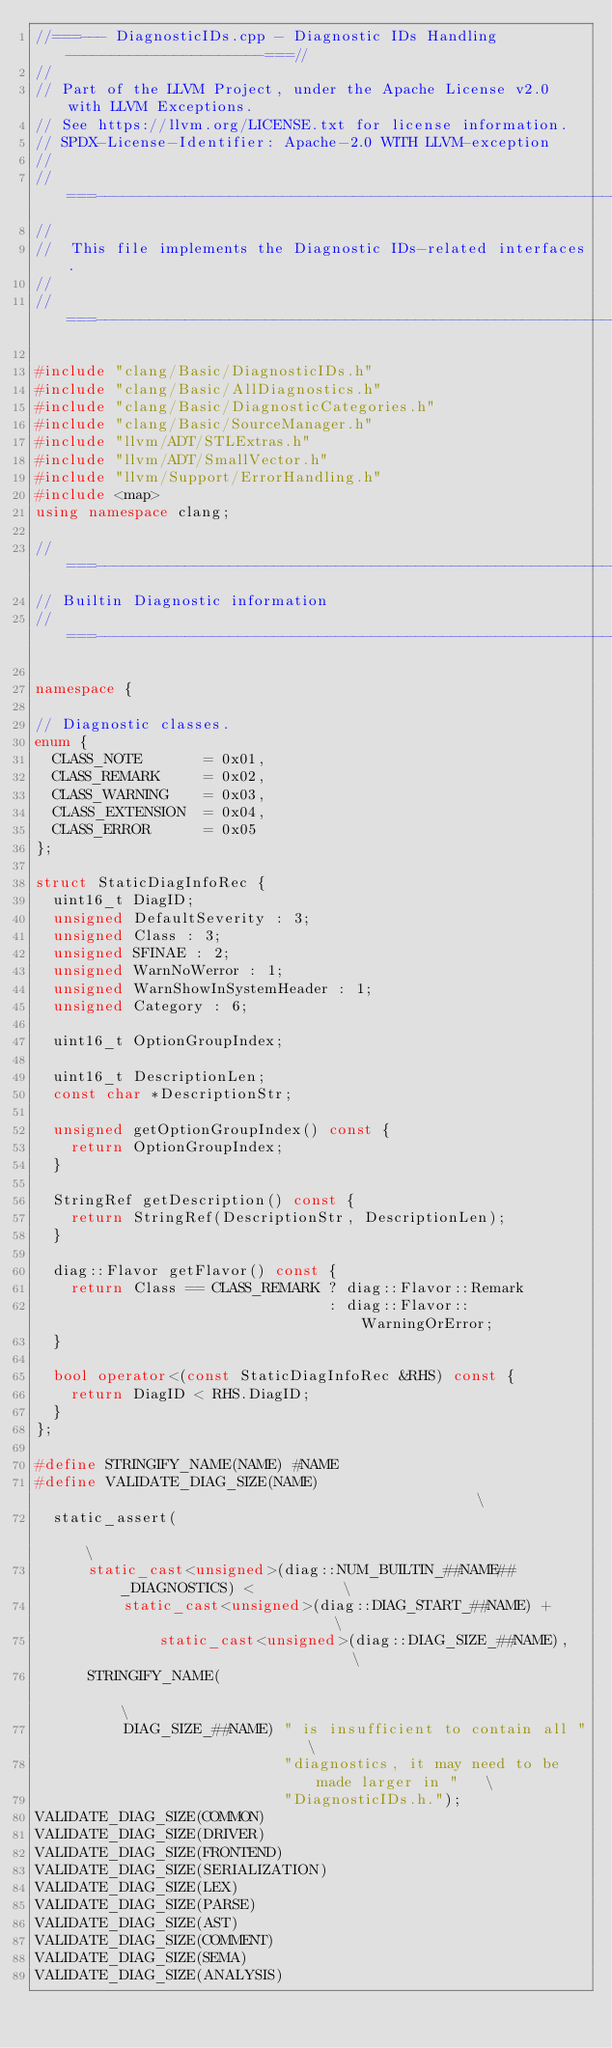Convert code to text. <code><loc_0><loc_0><loc_500><loc_500><_C++_>//===--- DiagnosticIDs.cpp - Diagnostic IDs Handling ----------------------===//
//
// Part of the LLVM Project, under the Apache License v2.0 with LLVM Exceptions.
// See https://llvm.org/LICENSE.txt for license information.
// SPDX-License-Identifier: Apache-2.0 WITH LLVM-exception
//
//===----------------------------------------------------------------------===//
//
//  This file implements the Diagnostic IDs-related interfaces.
//
//===----------------------------------------------------------------------===//

#include "clang/Basic/DiagnosticIDs.h"
#include "clang/Basic/AllDiagnostics.h"
#include "clang/Basic/DiagnosticCategories.h"
#include "clang/Basic/SourceManager.h"
#include "llvm/ADT/STLExtras.h"
#include "llvm/ADT/SmallVector.h"
#include "llvm/Support/ErrorHandling.h"
#include <map>
using namespace clang;

//===----------------------------------------------------------------------===//
// Builtin Diagnostic information
//===----------------------------------------------------------------------===//

namespace {

// Diagnostic classes.
enum {
  CLASS_NOTE       = 0x01,
  CLASS_REMARK     = 0x02,
  CLASS_WARNING    = 0x03,
  CLASS_EXTENSION  = 0x04,
  CLASS_ERROR      = 0x05
};

struct StaticDiagInfoRec {
  uint16_t DiagID;
  unsigned DefaultSeverity : 3;
  unsigned Class : 3;
  unsigned SFINAE : 2;
  unsigned WarnNoWerror : 1;
  unsigned WarnShowInSystemHeader : 1;
  unsigned Category : 6;

  uint16_t OptionGroupIndex;

  uint16_t DescriptionLen;
  const char *DescriptionStr;

  unsigned getOptionGroupIndex() const {
    return OptionGroupIndex;
  }

  StringRef getDescription() const {
    return StringRef(DescriptionStr, DescriptionLen);
  }

  diag::Flavor getFlavor() const {
    return Class == CLASS_REMARK ? diag::Flavor::Remark
                                 : diag::Flavor::WarningOrError;
  }

  bool operator<(const StaticDiagInfoRec &RHS) const {
    return DiagID < RHS.DiagID;
  }
};

#define STRINGIFY_NAME(NAME) #NAME
#define VALIDATE_DIAG_SIZE(NAME)                                               \
  static_assert(                                                               \
      static_cast<unsigned>(diag::NUM_BUILTIN_##NAME##_DIAGNOSTICS) <          \
          static_cast<unsigned>(diag::DIAG_START_##NAME) +                     \
              static_cast<unsigned>(diag::DIAG_SIZE_##NAME),                   \
      STRINGIFY_NAME(                                                          \
          DIAG_SIZE_##NAME) " is insufficient to contain all "                 \
                            "diagnostics, it may need to be made larger in "   \
                            "DiagnosticIDs.h.");
VALIDATE_DIAG_SIZE(COMMON)
VALIDATE_DIAG_SIZE(DRIVER)
VALIDATE_DIAG_SIZE(FRONTEND)
VALIDATE_DIAG_SIZE(SERIALIZATION)
VALIDATE_DIAG_SIZE(LEX)
VALIDATE_DIAG_SIZE(PARSE)
VALIDATE_DIAG_SIZE(AST)
VALIDATE_DIAG_SIZE(COMMENT)
VALIDATE_DIAG_SIZE(SEMA)
VALIDATE_DIAG_SIZE(ANALYSIS)</code> 